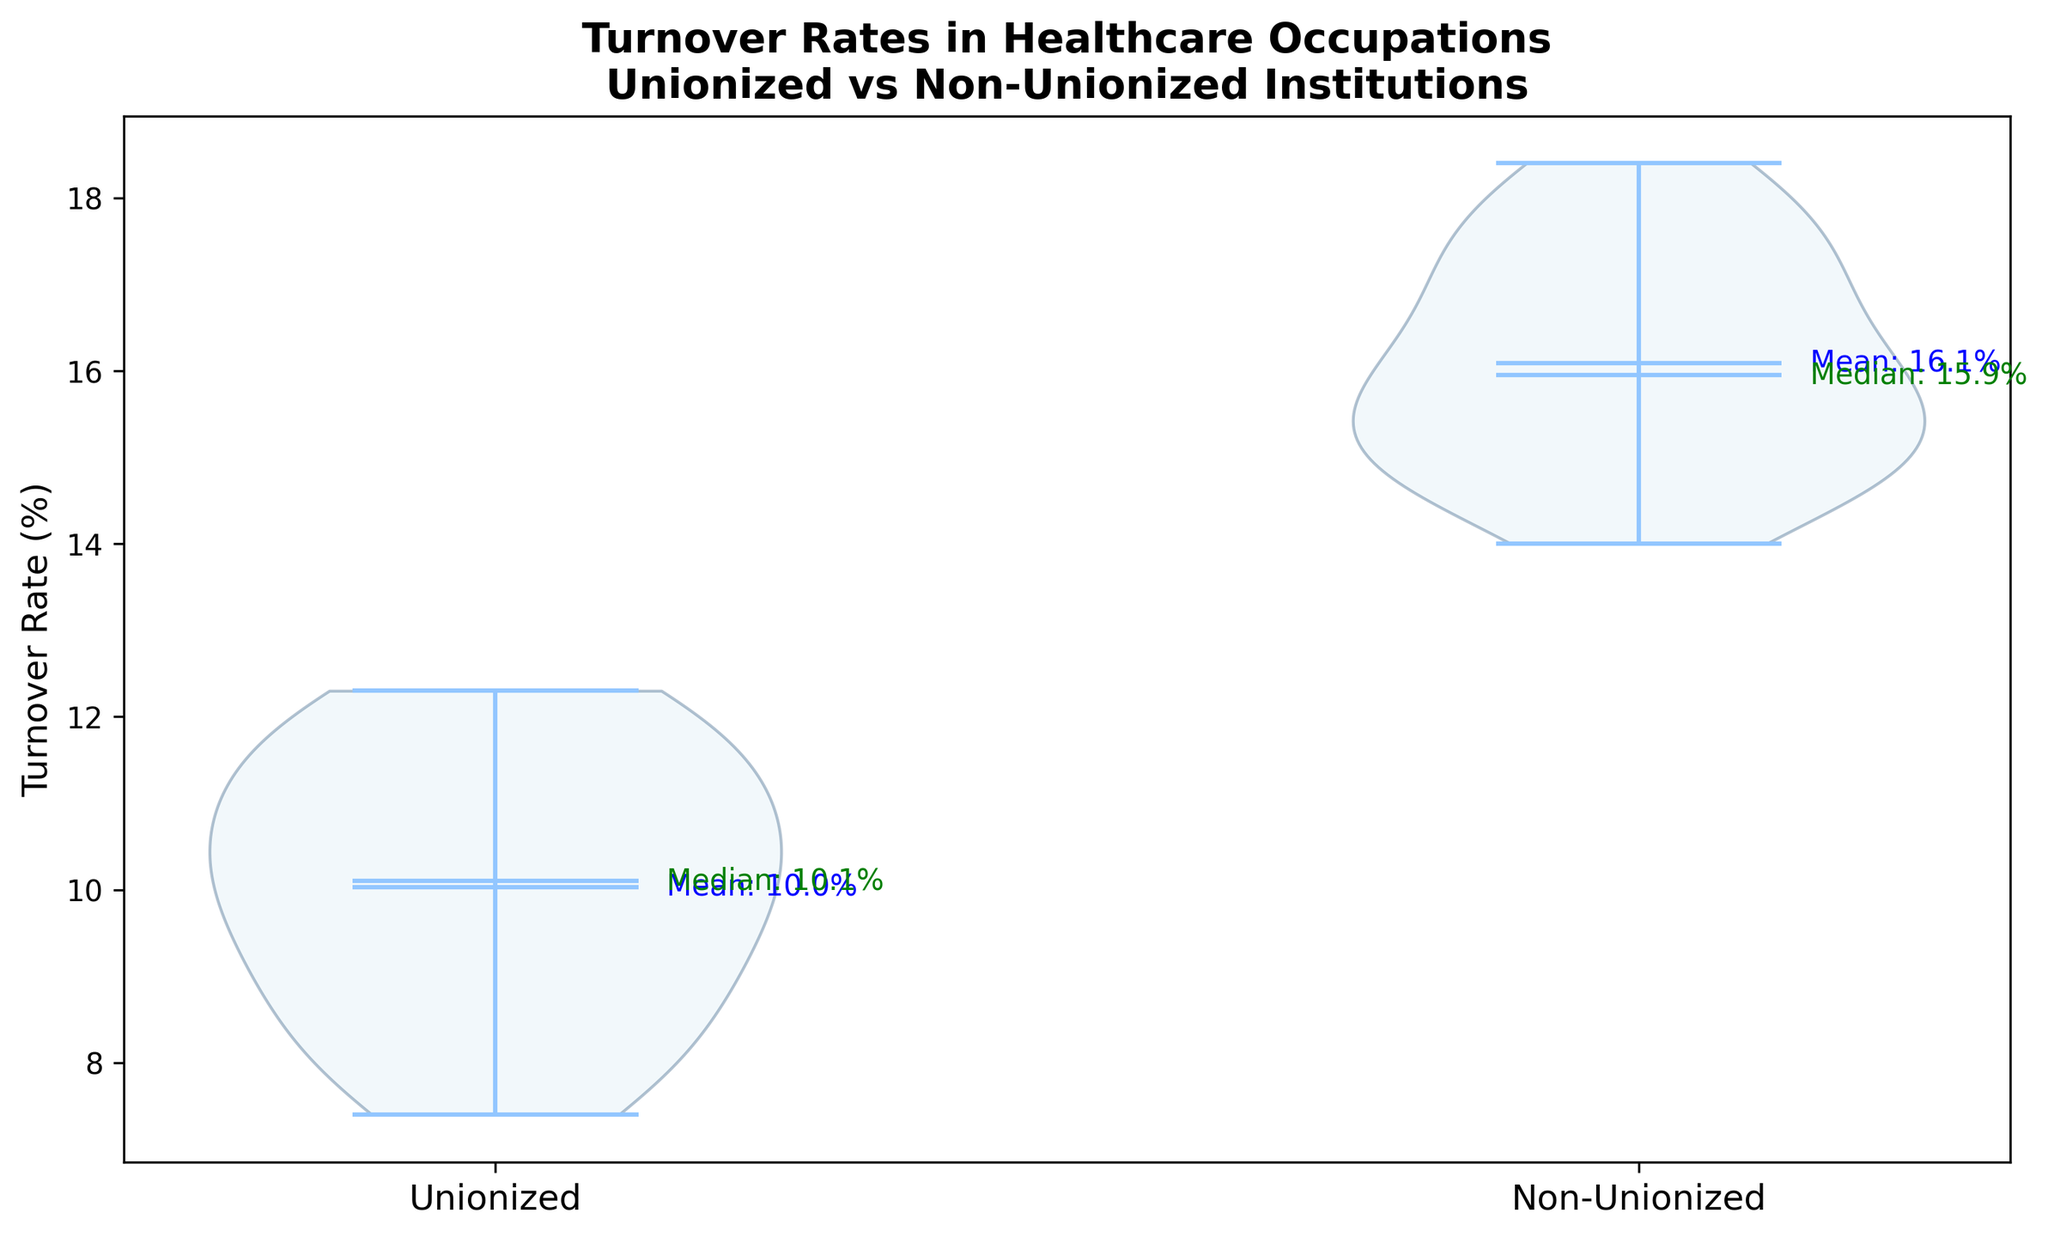What is the difference between the median turnover rate of unionized and non-unionized institutions? To determine the difference, identify the median turnover rates for both groups from the figure. The mediant labels on the plot show that the median for unionized institutions is 10% and for non-unionized institutions is 15.4%. The difference is 15.4% - 10% = 5.4%.
Answer: 5.4% Which group has a higher mean turnover rate? Identify the mean turnover rates for both groups from the mean labels in the figure. The mean for unionized institutions is 9.97%, and for non-unionized institutions is 16.09%. Since 16.09% is greater than 9.97%, the non-unionized institutions have a higher mean turnover rate.
Answer: Non-unionized institutions What is the range of turnover rates for unionized institutions? The range can be found by observing the highest and lowest points of the violin plot for unionized institutions. The lowest rate is about 7.4% and the highest is about 12.3%. The range is 12.3% - 7.4% = 4.9%.
Answer: 4.9% How does the spread of turnover rates compare between unionized and non-unionized institutions? The spread of the data is visually interpreted by the width and span of the violin plots for each group. The plot shows that non-unionized institutions have a wider violin plot, indicating a greater spread compared to unionized institutions. This suggests more variability in turnover rates among non-unionized institutions.
Answer: Non-unionized institutions have a greater spread What is the difference between the highest turnover rates in unionized and non-unionized institutions? Find the highest turnover rates from the top of each violin plot. For unionized institutions, the highest rate is 12.3%, and for non-unionized institutions, it is 18.4%. The difference is 18.4% - 12.3% = 6.1%.
Answer: 6.1% Do unionized institutions have any turnover rates lower than non-unionized institutions? Compare the lower end of the violin plots for both groups. The lowest rate for unionized institutions is 7.4%, while for non-unionized institutions, it is 14.0%. Since 7.4% is less than 14.0%, unionized institutions do have lower turnover rates than non-unionized institutions.
Answer: Yes How does the median turnover rate for non-unionized institutions compare to the mean turnover rate for unionized institutions? Identify the median turnover rate for non-unionized institutions and the mean turnover rate for unionized institutions from the plot's labels. The median for non-unionized is 15.4%, and the mean for unionized is 9.97%. Since 15.4% is greater than 9.97%, the median turnover rate for non-unionized institutions is higher.
Answer: Non-unionized median is higher By how much do the means of turnover rates differ between unionized and non-unionized institutions? Identify the mean turnover rates for each group from the figure. The mean for unionized institutions is 9.97%, and for non-unionized institutions is 16.09%. The difference is 16.09% - 9.97% = 6.12%.
Answer: 6.12% What is the interquartile range for the unionized institutions' turnover rates? The interquartile range (IQR) is the difference between the 75th and 25th percentiles. From the violin plot, these percentiles can be determined visually. The 25th percentile is around 8.6%, and the 75th percentile is around 11.1%. The IQR is 11.1% - 8.6% = 2.5%.
Answer: 2.5% 